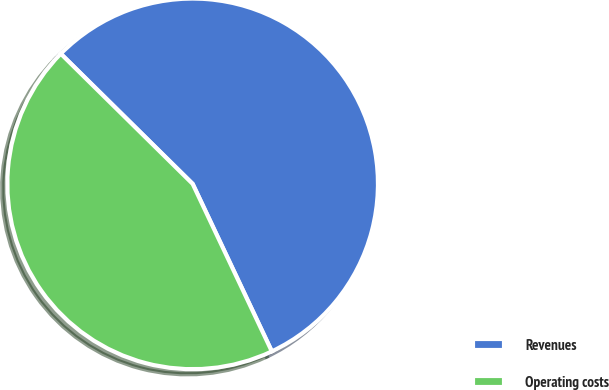Convert chart to OTSL. <chart><loc_0><loc_0><loc_500><loc_500><pie_chart><fcel>Revenues<fcel>Operating costs<nl><fcel>55.58%<fcel>44.42%<nl></chart> 